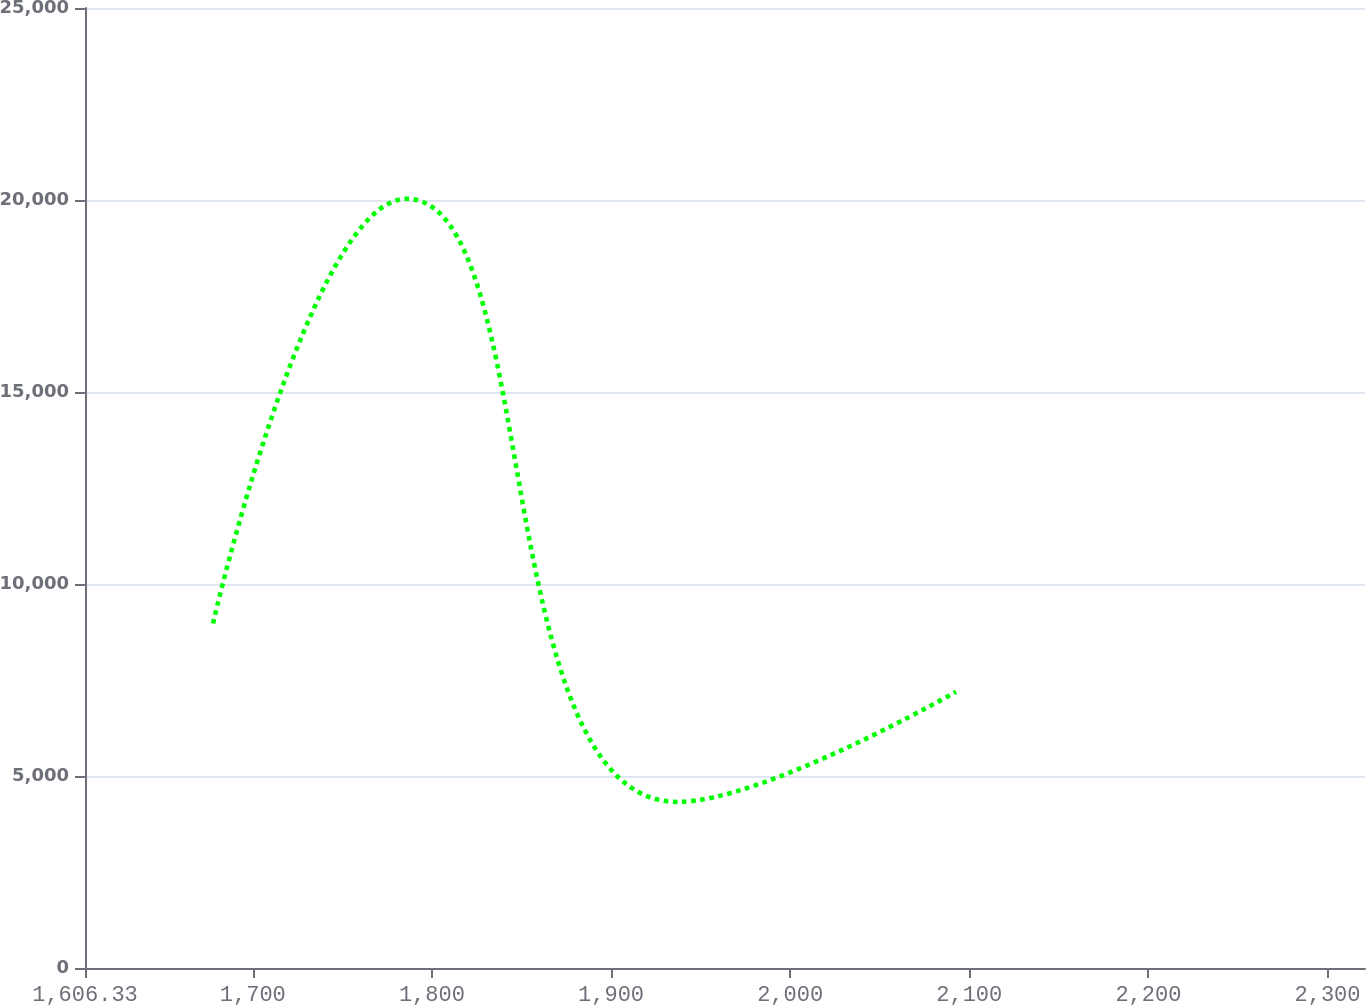Convert chart. <chart><loc_0><loc_0><loc_500><loc_500><line_chart><ecel><fcel>Unnamed: 1<nl><fcel>1677.79<fcel>8972.02<nl><fcel>1785.88<fcel>20030.8<nl><fcel>1937.06<fcel>4324.4<nl><fcel>2092.6<fcel>7195.15<nl><fcel>2392.39<fcel>2262.12<nl></chart> 